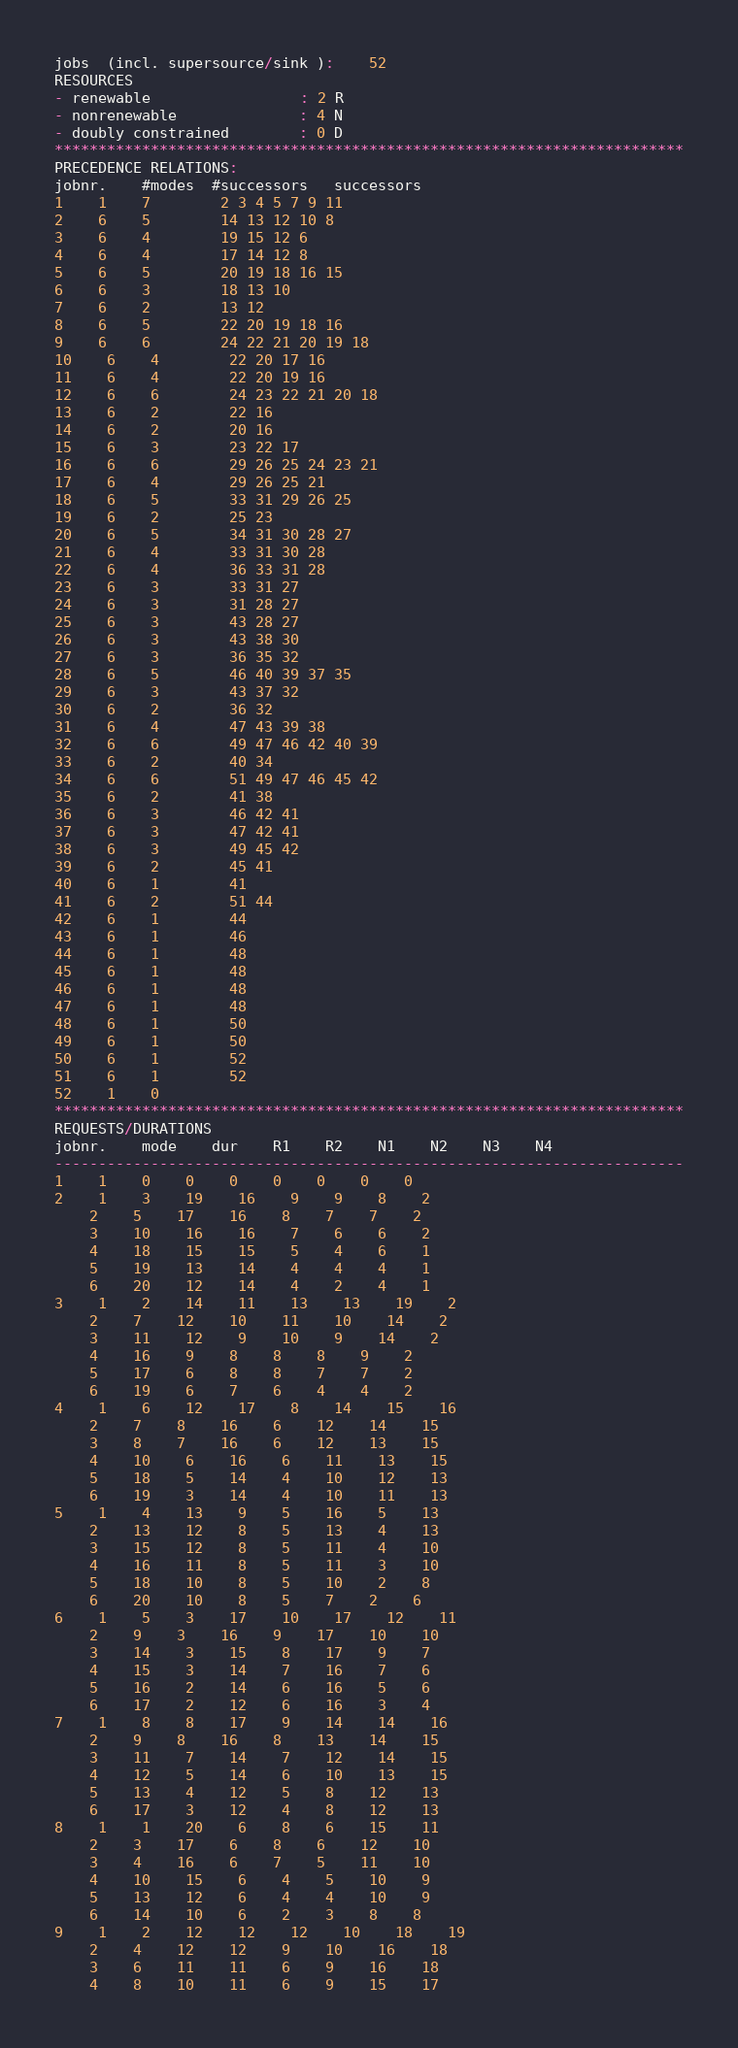Convert code to text. <code><loc_0><loc_0><loc_500><loc_500><_ObjectiveC_>jobs  (incl. supersource/sink ):	52
RESOURCES
- renewable                 : 2 R
- nonrenewable              : 4 N
- doubly constrained        : 0 D
************************************************************************
PRECEDENCE RELATIONS:
jobnr.    #modes  #successors   successors
1	1	7		2 3 4 5 7 9 11 
2	6	5		14 13 12 10 8 
3	6	4		19 15 12 6 
4	6	4		17 14 12 8 
5	6	5		20 19 18 16 15 
6	6	3		18 13 10 
7	6	2		13 12 
8	6	5		22 20 19 18 16 
9	6	6		24 22 21 20 19 18 
10	6	4		22 20 17 16 
11	6	4		22 20 19 16 
12	6	6		24 23 22 21 20 18 
13	6	2		22 16 
14	6	2		20 16 
15	6	3		23 22 17 
16	6	6		29 26 25 24 23 21 
17	6	4		29 26 25 21 
18	6	5		33 31 29 26 25 
19	6	2		25 23 
20	6	5		34 31 30 28 27 
21	6	4		33 31 30 28 
22	6	4		36 33 31 28 
23	6	3		33 31 27 
24	6	3		31 28 27 
25	6	3		43 28 27 
26	6	3		43 38 30 
27	6	3		36 35 32 
28	6	5		46 40 39 37 35 
29	6	3		43 37 32 
30	6	2		36 32 
31	6	4		47 43 39 38 
32	6	6		49 47 46 42 40 39 
33	6	2		40 34 
34	6	6		51 49 47 46 45 42 
35	6	2		41 38 
36	6	3		46 42 41 
37	6	3		47 42 41 
38	6	3		49 45 42 
39	6	2		45 41 
40	6	1		41 
41	6	2		51 44 
42	6	1		44 
43	6	1		46 
44	6	1		48 
45	6	1		48 
46	6	1		48 
47	6	1		48 
48	6	1		50 
49	6	1		50 
50	6	1		52 
51	6	1		52 
52	1	0		
************************************************************************
REQUESTS/DURATIONS
jobnr.	mode	dur	R1	R2	N1	N2	N3	N4	
------------------------------------------------------------------------
1	1	0	0	0	0	0	0	0	
2	1	3	19	16	9	9	8	2	
	2	5	17	16	8	7	7	2	
	3	10	16	16	7	6	6	2	
	4	18	15	15	5	4	6	1	
	5	19	13	14	4	4	4	1	
	6	20	12	14	4	2	4	1	
3	1	2	14	11	13	13	19	2	
	2	7	12	10	11	10	14	2	
	3	11	12	9	10	9	14	2	
	4	16	9	8	8	8	9	2	
	5	17	6	8	8	7	7	2	
	6	19	6	7	6	4	4	2	
4	1	6	12	17	8	14	15	16	
	2	7	8	16	6	12	14	15	
	3	8	7	16	6	12	13	15	
	4	10	6	16	6	11	13	15	
	5	18	5	14	4	10	12	13	
	6	19	3	14	4	10	11	13	
5	1	4	13	9	5	16	5	13	
	2	13	12	8	5	13	4	13	
	3	15	12	8	5	11	4	10	
	4	16	11	8	5	11	3	10	
	5	18	10	8	5	10	2	8	
	6	20	10	8	5	7	2	6	
6	1	5	3	17	10	17	12	11	
	2	9	3	16	9	17	10	10	
	3	14	3	15	8	17	9	7	
	4	15	3	14	7	16	7	6	
	5	16	2	14	6	16	5	6	
	6	17	2	12	6	16	3	4	
7	1	8	8	17	9	14	14	16	
	2	9	8	16	8	13	14	15	
	3	11	7	14	7	12	14	15	
	4	12	5	14	6	10	13	15	
	5	13	4	12	5	8	12	13	
	6	17	3	12	4	8	12	13	
8	1	1	20	6	8	6	15	11	
	2	3	17	6	8	6	12	10	
	3	4	16	6	7	5	11	10	
	4	10	15	6	4	5	10	9	
	5	13	12	6	4	4	10	9	
	6	14	10	6	2	3	8	8	
9	1	2	12	12	12	10	18	19	
	2	4	12	12	9	10	16	18	
	3	6	11	11	6	9	16	18	
	4	8	10	11	6	9	15	17	</code> 